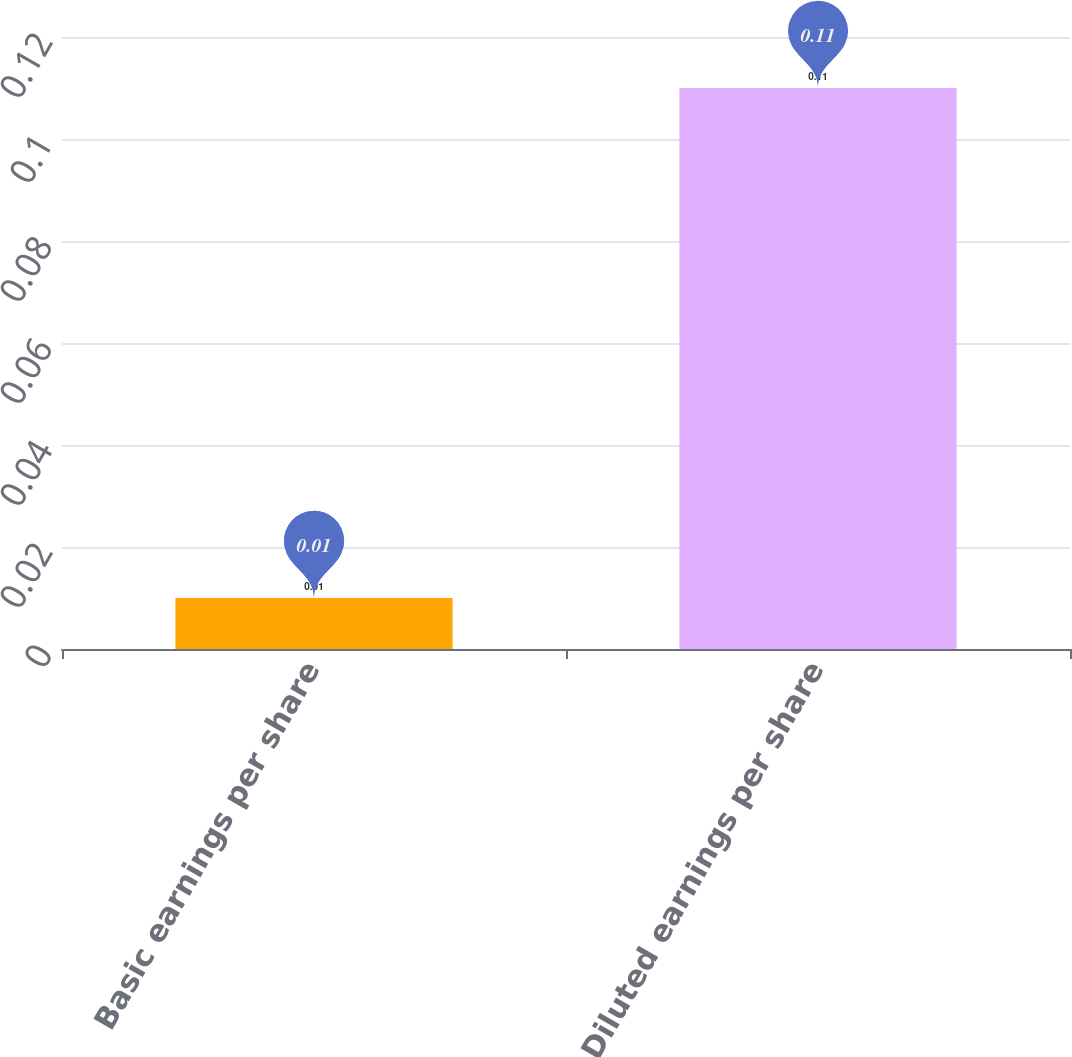Convert chart. <chart><loc_0><loc_0><loc_500><loc_500><bar_chart><fcel>Basic earnings per share<fcel>Diluted earnings per share<nl><fcel>0.01<fcel>0.11<nl></chart> 